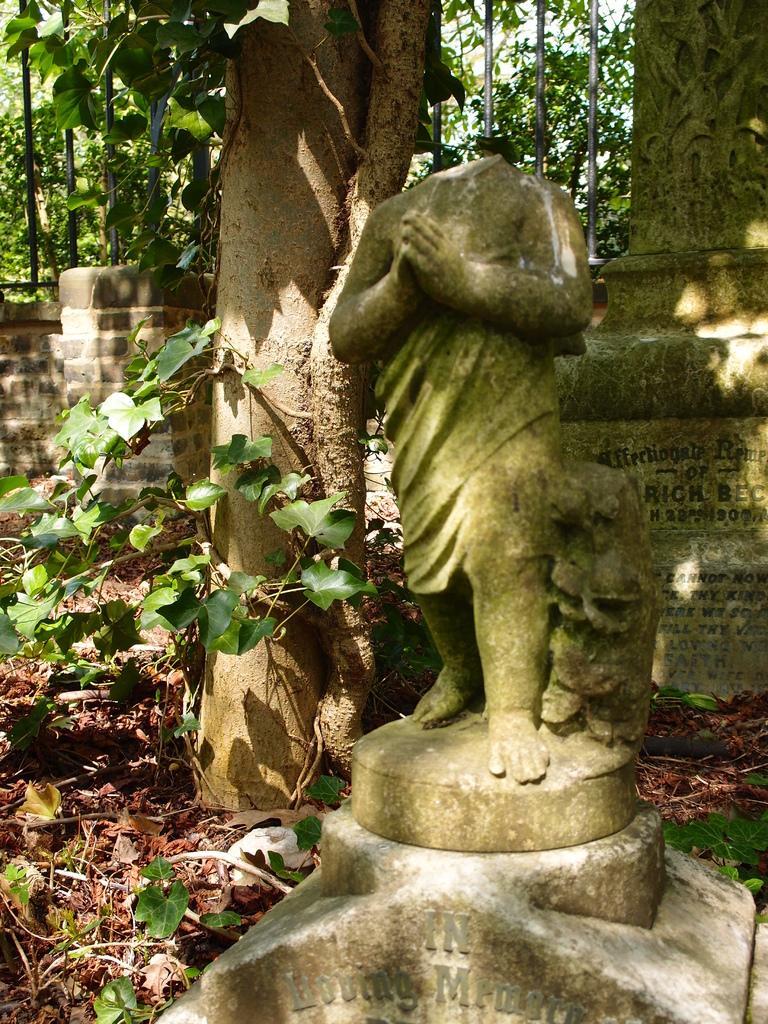Please provide a concise description of this image. In the foreground of the picture I can see the statue and the head of the statue is broken. I can see the trunk of a tree on the left side. There is a plant on the left side. In the background, I can see the metal grill fence and trees. 